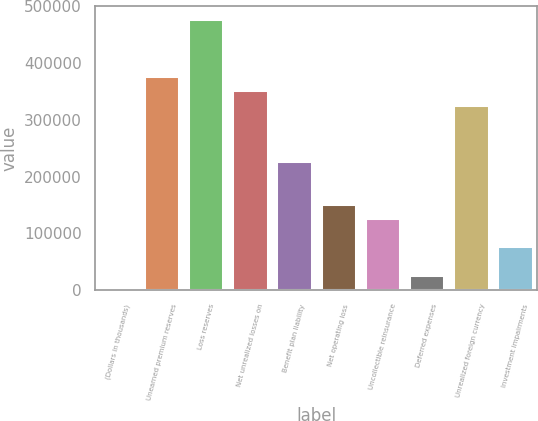Convert chart. <chart><loc_0><loc_0><loc_500><loc_500><bar_chart><fcel>(Dollars in thousands)<fcel>Unearned premium reserves<fcel>Loss reserves<fcel>Net unrealized losses on<fcel>Benefit plan liability<fcel>Net operating loss<fcel>Uncollectible reinsurance<fcel>Deferred expenses<fcel>Unrealized foreign currency<fcel>Investment impairments<nl><fcel>2016<fcel>377098<fcel>477120<fcel>352093<fcel>227066<fcel>152049<fcel>127044<fcel>27021.5<fcel>327088<fcel>77032.5<nl></chart> 